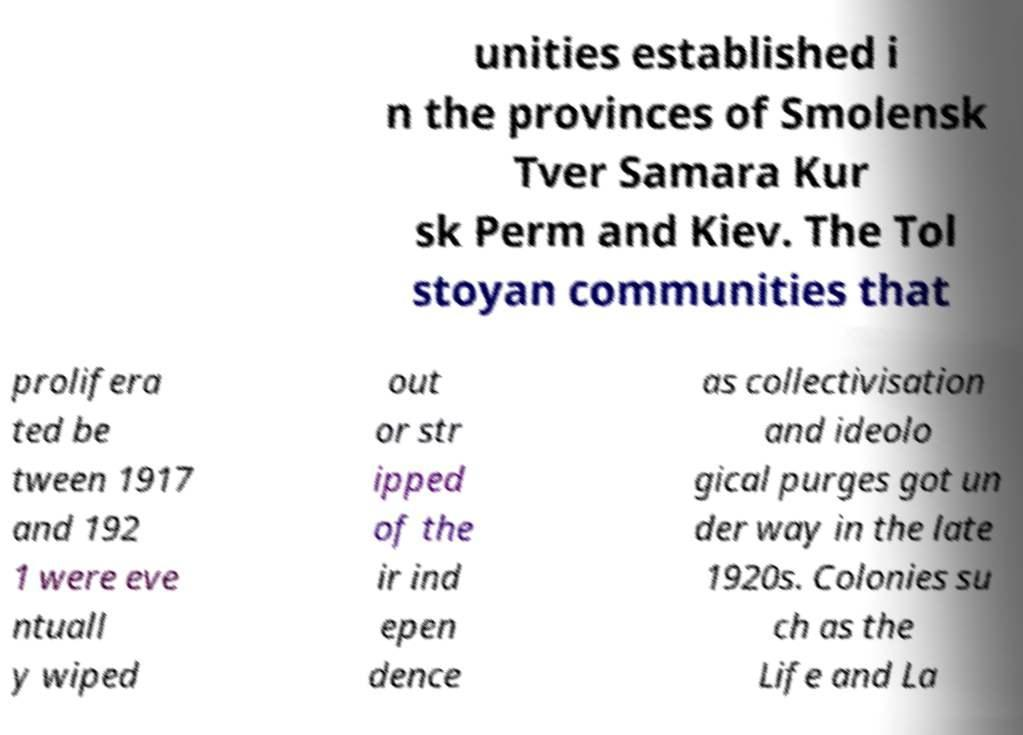Please identify and transcribe the text found in this image. unities established i n the provinces of Smolensk Tver Samara Kur sk Perm and Kiev. The Tol stoyan communities that prolifera ted be tween 1917 and 192 1 were eve ntuall y wiped out or str ipped of the ir ind epen dence as collectivisation and ideolo gical purges got un der way in the late 1920s. Colonies su ch as the Life and La 